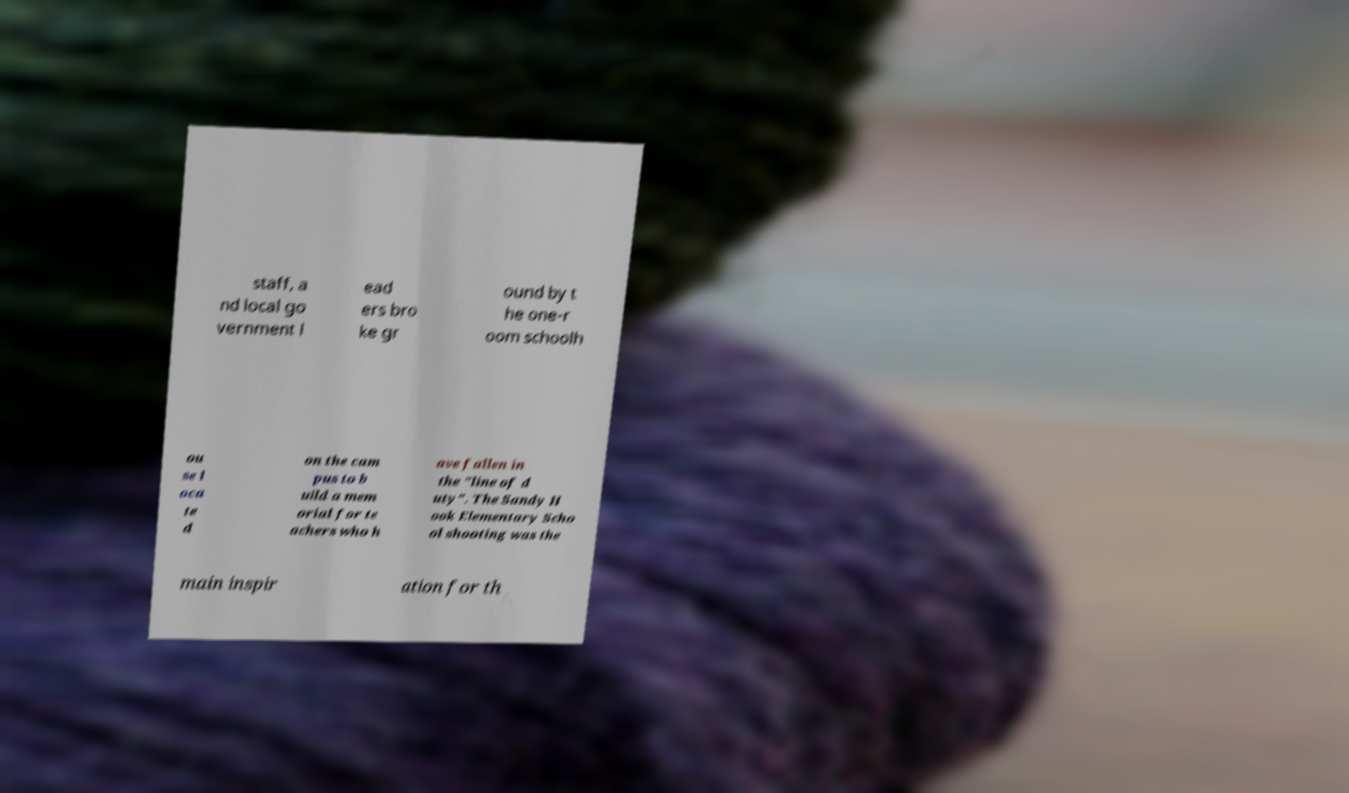Can you accurately transcribe the text from the provided image for me? staff, a nd local go vernment l ead ers bro ke gr ound by t he one-r oom schoolh ou se l oca te d on the cam pus to b uild a mem orial for te achers who h ave fallen in the "line of d uty". The Sandy H ook Elementary Scho ol shooting was the main inspir ation for th 